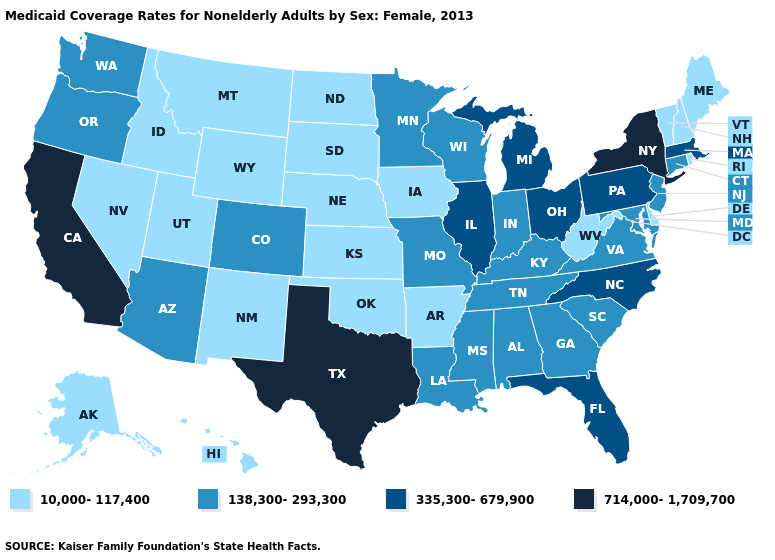Does Washington have a lower value than Ohio?
Write a very short answer. Yes. Name the states that have a value in the range 10,000-117,400?
Be succinct. Alaska, Arkansas, Delaware, Hawaii, Idaho, Iowa, Kansas, Maine, Montana, Nebraska, Nevada, New Hampshire, New Mexico, North Dakota, Oklahoma, Rhode Island, South Dakota, Utah, Vermont, West Virginia, Wyoming. Does South Carolina have the highest value in the USA?
Write a very short answer. No. Name the states that have a value in the range 10,000-117,400?
Write a very short answer. Alaska, Arkansas, Delaware, Hawaii, Idaho, Iowa, Kansas, Maine, Montana, Nebraska, Nevada, New Hampshire, New Mexico, North Dakota, Oklahoma, Rhode Island, South Dakota, Utah, Vermont, West Virginia, Wyoming. What is the lowest value in states that border Kansas?
Concise answer only. 10,000-117,400. Name the states that have a value in the range 714,000-1,709,700?
Quick response, please. California, New York, Texas. How many symbols are there in the legend?
Quick response, please. 4. Name the states that have a value in the range 10,000-117,400?
Concise answer only. Alaska, Arkansas, Delaware, Hawaii, Idaho, Iowa, Kansas, Maine, Montana, Nebraska, Nevada, New Hampshire, New Mexico, North Dakota, Oklahoma, Rhode Island, South Dakota, Utah, Vermont, West Virginia, Wyoming. Name the states that have a value in the range 138,300-293,300?
Keep it brief. Alabama, Arizona, Colorado, Connecticut, Georgia, Indiana, Kentucky, Louisiana, Maryland, Minnesota, Mississippi, Missouri, New Jersey, Oregon, South Carolina, Tennessee, Virginia, Washington, Wisconsin. Which states have the lowest value in the West?
Give a very brief answer. Alaska, Hawaii, Idaho, Montana, Nevada, New Mexico, Utah, Wyoming. Among the states that border California , which have the highest value?
Quick response, please. Arizona, Oregon. What is the value of New York?
Answer briefly. 714,000-1,709,700. Is the legend a continuous bar?
Quick response, please. No. Among the states that border North Carolina , which have the highest value?
Short answer required. Georgia, South Carolina, Tennessee, Virginia. What is the highest value in states that border California?
Keep it brief. 138,300-293,300. 